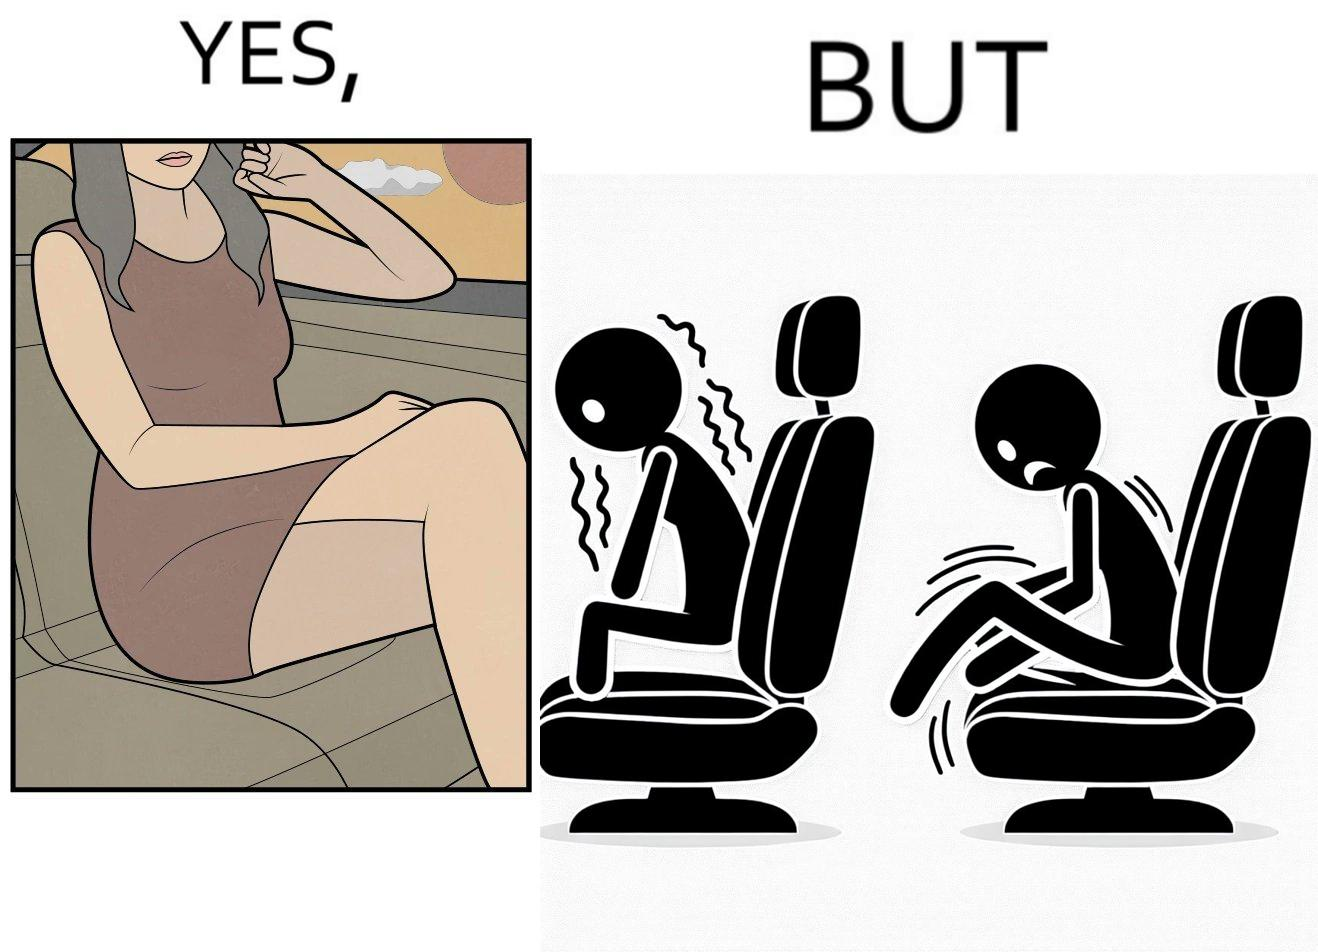Would you classify this image as satirical? Yes, this image is satirical. 